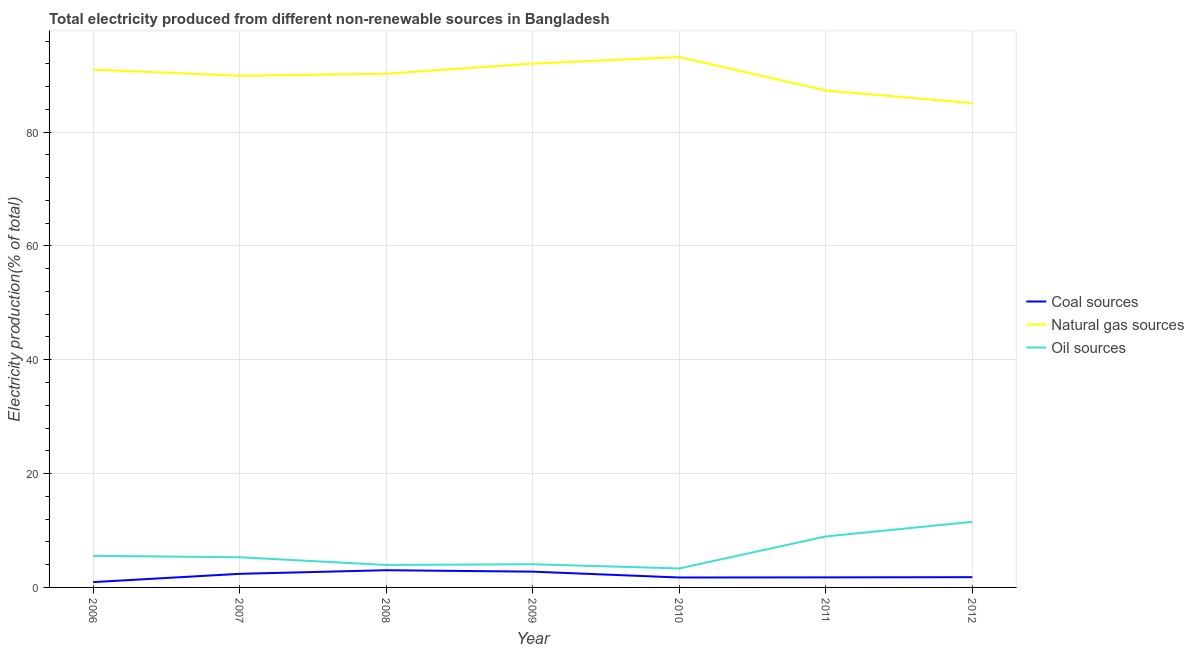How many different coloured lines are there?
Ensure brevity in your answer.  3. Does the line corresponding to percentage of electricity produced by oil sources intersect with the line corresponding to percentage of electricity produced by natural gas?
Your answer should be compact. No. Is the number of lines equal to the number of legend labels?
Provide a succinct answer. Yes. What is the percentage of electricity produced by oil sources in 2007?
Offer a terse response. 5.3. Across all years, what is the maximum percentage of electricity produced by natural gas?
Offer a terse response. 93.18. Across all years, what is the minimum percentage of electricity produced by coal?
Ensure brevity in your answer.  0.93. In which year was the percentage of electricity produced by oil sources minimum?
Give a very brief answer. 2010. What is the total percentage of electricity produced by oil sources in the graph?
Offer a very short reply. 42.69. What is the difference between the percentage of electricity produced by natural gas in 2009 and that in 2011?
Make the answer very short. 4.73. What is the difference between the percentage of electricity produced by natural gas in 2012 and the percentage of electricity produced by oil sources in 2006?
Keep it short and to the point. 79.54. What is the average percentage of electricity produced by coal per year?
Give a very brief answer. 2.06. In the year 2012, what is the difference between the percentage of electricity produced by coal and percentage of electricity produced by natural gas?
Your answer should be very brief. -83.29. What is the ratio of the percentage of electricity produced by coal in 2010 to that in 2011?
Offer a very short reply. 0.99. What is the difference between the highest and the second highest percentage of electricity produced by natural gas?
Offer a very short reply. 1.14. What is the difference between the highest and the lowest percentage of electricity produced by oil sources?
Provide a succinct answer. 8.19. Is the sum of the percentage of electricity produced by natural gas in 2008 and 2009 greater than the maximum percentage of electricity produced by oil sources across all years?
Ensure brevity in your answer.  Yes. Does the percentage of electricity produced by natural gas monotonically increase over the years?
Give a very brief answer. No. Is the percentage of electricity produced by oil sources strictly less than the percentage of electricity produced by natural gas over the years?
Your answer should be very brief. Yes. How many lines are there?
Your answer should be compact. 3. How many years are there in the graph?
Offer a terse response. 7. Where does the legend appear in the graph?
Your answer should be compact. Center right. How are the legend labels stacked?
Provide a succinct answer. Vertical. What is the title of the graph?
Provide a succinct answer. Total electricity produced from different non-renewable sources in Bangladesh. What is the label or title of the Y-axis?
Offer a terse response. Electricity production(% of total). What is the Electricity production(% of total) of Coal sources in 2006?
Your response must be concise. 0.93. What is the Electricity production(% of total) in Natural gas sources in 2006?
Provide a succinct answer. 90.98. What is the Electricity production(% of total) in Oil sources in 2006?
Offer a terse response. 5.55. What is the Electricity production(% of total) in Coal sources in 2007?
Offer a terse response. 2.39. What is the Electricity production(% of total) in Natural gas sources in 2007?
Give a very brief answer. 89.9. What is the Electricity production(% of total) of Oil sources in 2007?
Offer a very short reply. 5.3. What is the Electricity production(% of total) of Coal sources in 2008?
Keep it short and to the point. 3.02. What is the Electricity production(% of total) of Natural gas sources in 2008?
Offer a very short reply. 90.26. What is the Electricity production(% of total) in Oil sources in 2008?
Your answer should be compact. 3.95. What is the Electricity production(% of total) of Coal sources in 2009?
Your answer should be very brief. 2.77. What is the Electricity production(% of total) of Natural gas sources in 2009?
Your answer should be very brief. 92.03. What is the Electricity production(% of total) in Oil sources in 2009?
Make the answer very short. 4.08. What is the Electricity production(% of total) of Coal sources in 2010?
Your answer should be very brief. 1.74. What is the Electricity production(% of total) of Natural gas sources in 2010?
Keep it short and to the point. 93.18. What is the Electricity production(% of total) of Oil sources in 2010?
Offer a terse response. 3.33. What is the Electricity production(% of total) in Coal sources in 2011?
Give a very brief answer. 1.77. What is the Electricity production(% of total) in Natural gas sources in 2011?
Give a very brief answer. 87.31. What is the Electricity production(% of total) in Oil sources in 2011?
Give a very brief answer. 8.95. What is the Electricity production(% of total) in Coal sources in 2012?
Give a very brief answer. 1.8. What is the Electricity production(% of total) in Natural gas sources in 2012?
Give a very brief answer. 85.09. What is the Electricity production(% of total) in Oil sources in 2012?
Give a very brief answer. 11.53. Across all years, what is the maximum Electricity production(% of total) in Coal sources?
Provide a succinct answer. 3.02. Across all years, what is the maximum Electricity production(% of total) in Natural gas sources?
Ensure brevity in your answer.  93.18. Across all years, what is the maximum Electricity production(% of total) of Oil sources?
Your answer should be compact. 11.53. Across all years, what is the minimum Electricity production(% of total) in Coal sources?
Provide a short and direct response. 0.93. Across all years, what is the minimum Electricity production(% of total) of Natural gas sources?
Offer a terse response. 85.09. Across all years, what is the minimum Electricity production(% of total) of Oil sources?
Keep it short and to the point. 3.33. What is the total Electricity production(% of total) of Coal sources in the graph?
Your response must be concise. 14.43. What is the total Electricity production(% of total) in Natural gas sources in the graph?
Your response must be concise. 628.74. What is the total Electricity production(% of total) in Oil sources in the graph?
Offer a terse response. 42.69. What is the difference between the Electricity production(% of total) in Coal sources in 2006 and that in 2007?
Your answer should be very brief. -1.46. What is the difference between the Electricity production(% of total) of Oil sources in 2006 and that in 2007?
Provide a succinct answer. 0.25. What is the difference between the Electricity production(% of total) in Coal sources in 2006 and that in 2008?
Provide a short and direct response. -2.09. What is the difference between the Electricity production(% of total) in Natural gas sources in 2006 and that in 2008?
Give a very brief answer. 0.72. What is the difference between the Electricity production(% of total) in Oil sources in 2006 and that in 2008?
Your answer should be compact. 1.6. What is the difference between the Electricity production(% of total) in Coal sources in 2006 and that in 2009?
Provide a succinct answer. -1.84. What is the difference between the Electricity production(% of total) of Natural gas sources in 2006 and that in 2009?
Your answer should be compact. -1.06. What is the difference between the Electricity production(% of total) in Oil sources in 2006 and that in 2009?
Give a very brief answer. 1.48. What is the difference between the Electricity production(% of total) in Coal sources in 2006 and that in 2010?
Give a very brief answer. -0.81. What is the difference between the Electricity production(% of total) in Natural gas sources in 2006 and that in 2010?
Give a very brief answer. -2.2. What is the difference between the Electricity production(% of total) of Oil sources in 2006 and that in 2010?
Provide a short and direct response. 2.22. What is the difference between the Electricity production(% of total) of Coal sources in 2006 and that in 2011?
Provide a succinct answer. -0.83. What is the difference between the Electricity production(% of total) in Natural gas sources in 2006 and that in 2011?
Offer a terse response. 3.67. What is the difference between the Electricity production(% of total) of Oil sources in 2006 and that in 2011?
Your response must be concise. -3.4. What is the difference between the Electricity production(% of total) of Coal sources in 2006 and that in 2012?
Give a very brief answer. -0.87. What is the difference between the Electricity production(% of total) of Natural gas sources in 2006 and that in 2012?
Your answer should be very brief. 5.89. What is the difference between the Electricity production(% of total) in Oil sources in 2006 and that in 2012?
Keep it short and to the point. -5.97. What is the difference between the Electricity production(% of total) of Coal sources in 2007 and that in 2008?
Make the answer very short. -0.64. What is the difference between the Electricity production(% of total) of Natural gas sources in 2007 and that in 2008?
Keep it short and to the point. -0.36. What is the difference between the Electricity production(% of total) of Oil sources in 2007 and that in 2008?
Your answer should be compact. 1.35. What is the difference between the Electricity production(% of total) of Coal sources in 2007 and that in 2009?
Your answer should be compact. -0.38. What is the difference between the Electricity production(% of total) of Natural gas sources in 2007 and that in 2009?
Your answer should be compact. -2.14. What is the difference between the Electricity production(% of total) in Oil sources in 2007 and that in 2009?
Offer a terse response. 1.22. What is the difference between the Electricity production(% of total) of Coal sources in 2007 and that in 2010?
Provide a short and direct response. 0.65. What is the difference between the Electricity production(% of total) in Natural gas sources in 2007 and that in 2010?
Keep it short and to the point. -3.28. What is the difference between the Electricity production(% of total) in Oil sources in 2007 and that in 2010?
Ensure brevity in your answer.  1.96. What is the difference between the Electricity production(% of total) in Coal sources in 2007 and that in 2011?
Make the answer very short. 0.62. What is the difference between the Electricity production(% of total) in Natural gas sources in 2007 and that in 2011?
Your answer should be compact. 2.59. What is the difference between the Electricity production(% of total) in Oil sources in 2007 and that in 2011?
Keep it short and to the point. -3.66. What is the difference between the Electricity production(% of total) of Coal sources in 2007 and that in 2012?
Your answer should be very brief. 0.59. What is the difference between the Electricity production(% of total) in Natural gas sources in 2007 and that in 2012?
Your answer should be very brief. 4.81. What is the difference between the Electricity production(% of total) in Oil sources in 2007 and that in 2012?
Provide a short and direct response. -6.23. What is the difference between the Electricity production(% of total) of Coal sources in 2008 and that in 2009?
Offer a terse response. 0.25. What is the difference between the Electricity production(% of total) of Natural gas sources in 2008 and that in 2009?
Ensure brevity in your answer.  -1.78. What is the difference between the Electricity production(% of total) in Oil sources in 2008 and that in 2009?
Provide a short and direct response. -0.13. What is the difference between the Electricity production(% of total) in Coal sources in 2008 and that in 2010?
Keep it short and to the point. 1.28. What is the difference between the Electricity production(% of total) in Natural gas sources in 2008 and that in 2010?
Your answer should be compact. -2.92. What is the difference between the Electricity production(% of total) in Oil sources in 2008 and that in 2010?
Offer a terse response. 0.61. What is the difference between the Electricity production(% of total) of Coal sources in 2008 and that in 2011?
Offer a terse response. 1.26. What is the difference between the Electricity production(% of total) of Natural gas sources in 2008 and that in 2011?
Provide a succinct answer. 2.95. What is the difference between the Electricity production(% of total) in Oil sources in 2008 and that in 2011?
Your answer should be compact. -5. What is the difference between the Electricity production(% of total) of Coal sources in 2008 and that in 2012?
Keep it short and to the point. 1.22. What is the difference between the Electricity production(% of total) of Natural gas sources in 2008 and that in 2012?
Offer a very short reply. 5.17. What is the difference between the Electricity production(% of total) in Oil sources in 2008 and that in 2012?
Your answer should be very brief. -7.58. What is the difference between the Electricity production(% of total) in Coal sources in 2009 and that in 2010?
Provide a succinct answer. 1.03. What is the difference between the Electricity production(% of total) in Natural gas sources in 2009 and that in 2010?
Ensure brevity in your answer.  -1.14. What is the difference between the Electricity production(% of total) in Oil sources in 2009 and that in 2010?
Ensure brevity in your answer.  0.74. What is the difference between the Electricity production(% of total) of Natural gas sources in 2009 and that in 2011?
Your answer should be compact. 4.73. What is the difference between the Electricity production(% of total) in Oil sources in 2009 and that in 2011?
Make the answer very short. -4.88. What is the difference between the Electricity production(% of total) in Coal sources in 2009 and that in 2012?
Your response must be concise. 0.97. What is the difference between the Electricity production(% of total) in Natural gas sources in 2009 and that in 2012?
Keep it short and to the point. 6.95. What is the difference between the Electricity production(% of total) in Oil sources in 2009 and that in 2012?
Make the answer very short. -7.45. What is the difference between the Electricity production(% of total) of Coal sources in 2010 and that in 2011?
Your answer should be compact. -0.02. What is the difference between the Electricity production(% of total) of Natural gas sources in 2010 and that in 2011?
Offer a very short reply. 5.87. What is the difference between the Electricity production(% of total) of Oil sources in 2010 and that in 2011?
Your response must be concise. -5.62. What is the difference between the Electricity production(% of total) of Coal sources in 2010 and that in 2012?
Your answer should be very brief. -0.06. What is the difference between the Electricity production(% of total) in Natural gas sources in 2010 and that in 2012?
Ensure brevity in your answer.  8.09. What is the difference between the Electricity production(% of total) of Oil sources in 2010 and that in 2012?
Keep it short and to the point. -8.19. What is the difference between the Electricity production(% of total) in Coal sources in 2011 and that in 2012?
Offer a very short reply. -0.03. What is the difference between the Electricity production(% of total) in Natural gas sources in 2011 and that in 2012?
Offer a very short reply. 2.22. What is the difference between the Electricity production(% of total) in Oil sources in 2011 and that in 2012?
Your answer should be very brief. -2.57. What is the difference between the Electricity production(% of total) in Coal sources in 2006 and the Electricity production(% of total) in Natural gas sources in 2007?
Keep it short and to the point. -88.96. What is the difference between the Electricity production(% of total) of Coal sources in 2006 and the Electricity production(% of total) of Oil sources in 2007?
Make the answer very short. -4.36. What is the difference between the Electricity production(% of total) in Natural gas sources in 2006 and the Electricity production(% of total) in Oil sources in 2007?
Keep it short and to the point. 85.68. What is the difference between the Electricity production(% of total) in Coal sources in 2006 and the Electricity production(% of total) in Natural gas sources in 2008?
Make the answer very short. -89.32. What is the difference between the Electricity production(% of total) in Coal sources in 2006 and the Electricity production(% of total) in Oil sources in 2008?
Make the answer very short. -3.01. What is the difference between the Electricity production(% of total) in Natural gas sources in 2006 and the Electricity production(% of total) in Oil sources in 2008?
Make the answer very short. 87.03. What is the difference between the Electricity production(% of total) in Coal sources in 2006 and the Electricity production(% of total) in Natural gas sources in 2009?
Offer a very short reply. -91.1. What is the difference between the Electricity production(% of total) of Coal sources in 2006 and the Electricity production(% of total) of Oil sources in 2009?
Make the answer very short. -3.14. What is the difference between the Electricity production(% of total) in Natural gas sources in 2006 and the Electricity production(% of total) in Oil sources in 2009?
Provide a succinct answer. 86.9. What is the difference between the Electricity production(% of total) in Coal sources in 2006 and the Electricity production(% of total) in Natural gas sources in 2010?
Keep it short and to the point. -92.24. What is the difference between the Electricity production(% of total) of Coal sources in 2006 and the Electricity production(% of total) of Oil sources in 2010?
Give a very brief answer. -2.4. What is the difference between the Electricity production(% of total) of Natural gas sources in 2006 and the Electricity production(% of total) of Oil sources in 2010?
Give a very brief answer. 87.64. What is the difference between the Electricity production(% of total) in Coal sources in 2006 and the Electricity production(% of total) in Natural gas sources in 2011?
Offer a terse response. -86.37. What is the difference between the Electricity production(% of total) of Coal sources in 2006 and the Electricity production(% of total) of Oil sources in 2011?
Provide a succinct answer. -8.02. What is the difference between the Electricity production(% of total) of Natural gas sources in 2006 and the Electricity production(% of total) of Oil sources in 2011?
Provide a succinct answer. 82.02. What is the difference between the Electricity production(% of total) of Coal sources in 2006 and the Electricity production(% of total) of Natural gas sources in 2012?
Offer a terse response. -84.16. What is the difference between the Electricity production(% of total) of Coal sources in 2006 and the Electricity production(% of total) of Oil sources in 2012?
Keep it short and to the point. -10.59. What is the difference between the Electricity production(% of total) in Natural gas sources in 2006 and the Electricity production(% of total) in Oil sources in 2012?
Offer a terse response. 79.45. What is the difference between the Electricity production(% of total) in Coal sources in 2007 and the Electricity production(% of total) in Natural gas sources in 2008?
Your response must be concise. -87.87. What is the difference between the Electricity production(% of total) in Coal sources in 2007 and the Electricity production(% of total) in Oil sources in 2008?
Give a very brief answer. -1.56. What is the difference between the Electricity production(% of total) of Natural gas sources in 2007 and the Electricity production(% of total) of Oil sources in 2008?
Keep it short and to the point. 85.95. What is the difference between the Electricity production(% of total) of Coal sources in 2007 and the Electricity production(% of total) of Natural gas sources in 2009?
Make the answer very short. -89.65. What is the difference between the Electricity production(% of total) in Coal sources in 2007 and the Electricity production(% of total) in Oil sources in 2009?
Offer a terse response. -1.69. What is the difference between the Electricity production(% of total) in Natural gas sources in 2007 and the Electricity production(% of total) in Oil sources in 2009?
Keep it short and to the point. 85.82. What is the difference between the Electricity production(% of total) of Coal sources in 2007 and the Electricity production(% of total) of Natural gas sources in 2010?
Provide a short and direct response. -90.79. What is the difference between the Electricity production(% of total) in Coal sources in 2007 and the Electricity production(% of total) in Oil sources in 2010?
Ensure brevity in your answer.  -0.94. What is the difference between the Electricity production(% of total) of Natural gas sources in 2007 and the Electricity production(% of total) of Oil sources in 2010?
Ensure brevity in your answer.  86.56. What is the difference between the Electricity production(% of total) of Coal sources in 2007 and the Electricity production(% of total) of Natural gas sources in 2011?
Offer a terse response. -84.92. What is the difference between the Electricity production(% of total) of Coal sources in 2007 and the Electricity production(% of total) of Oil sources in 2011?
Make the answer very short. -6.56. What is the difference between the Electricity production(% of total) of Natural gas sources in 2007 and the Electricity production(% of total) of Oil sources in 2011?
Your response must be concise. 80.94. What is the difference between the Electricity production(% of total) of Coal sources in 2007 and the Electricity production(% of total) of Natural gas sources in 2012?
Provide a short and direct response. -82.7. What is the difference between the Electricity production(% of total) in Coal sources in 2007 and the Electricity production(% of total) in Oil sources in 2012?
Your answer should be very brief. -9.14. What is the difference between the Electricity production(% of total) of Natural gas sources in 2007 and the Electricity production(% of total) of Oil sources in 2012?
Your answer should be very brief. 78.37. What is the difference between the Electricity production(% of total) in Coal sources in 2008 and the Electricity production(% of total) in Natural gas sources in 2009?
Keep it short and to the point. -89.01. What is the difference between the Electricity production(% of total) of Coal sources in 2008 and the Electricity production(% of total) of Oil sources in 2009?
Offer a very short reply. -1.05. What is the difference between the Electricity production(% of total) in Natural gas sources in 2008 and the Electricity production(% of total) in Oil sources in 2009?
Your answer should be very brief. 86.18. What is the difference between the Electricity production(% of total) of Coal sources in 2008 and the Electricity production(% of total) of Natural gas sources in 2010?
Your response must be concise. -90.15. What is the difference between the Electricity production(% of total) in Coal sources in 2008 and the Electricity production(% of total) in Oil sources in 2010?
Offer a very short reply. -0.31. What is the difference between the Electricity production(% of total) in Natural gas sources in 2008 and the Electricity production(% of total) in Oil sources in 2010?
Provide a short and direct response. 86.93. What is the difference between the Electricity production(% of total) in Coal sources in 2008 and the Electricity production(% of total) in Natural gas sources in 2011?
Provide a short and direct response. -84.28. What is the difference between the Electricity production(% of total) in Coal sources in 2008 and the Electricity production(% of total) in Oil sources in 2011?
Ensure brevity in your answer.  -5.93. What is the difference between the Electricity production(% of total) of Natural gas sources in 2008 and the Electricity production(% of total) of Oil sources in 2011?
Your answer should be very brief. 81.31. What is the difference between the Electricity production(% of total) in Coal sources in 2008 and the Electricity production(% of total) in Natural gas sources in 2012?
Provide a short and direct response. -82.06. What is the difference between the Electricity production(% of total) in Coal sources in 2008 and the Electricity production(% of total) in Oil sources in 2012?
Make the answer very short. -8.5. What is the difference between the Electricity production(% of total) of Natural gas sources in 2008 and the Electricity production(% of total) of Oil sources in 2012?
Your answer should be very brief. 78.73. What is the difference between the Electricity production(% of total) of Coal sources in 2009 and the Electricity production(% of total) of Natural gas sources in 2010?
Provide a succinct answer. -90.41. What is the difference between the Electricity production(% of total) of Coal sources in 2009 and the Electricity production(% of total) of Oil sources in 2010?
Your answer should be compact. -0.56. What is the difference between the Electricity production(% of total) of Natural gas sources in 2009 and the Electricity production(% of total) of Oil sources in 2010?
Provide a short and direct response. 88.7. What is the difference between the Electricity production(% of total) of Coal sources in 2009 and the Electricity production(% of total) of Natural gas sources in 2011?
Provide a short and direct response. -84.54. What is the difference between the Electricity production(% of total) in Coal sources in 2009 and the Electricity production(% of total) in Oil sources in 2011?
Your response must be concise. -6.18. What is the difference between the Electricity production(% of total) of Natural gas sources in 2009 and the Electricity production(% of total) of Oil sources in 2011?
Give a very brief answer. 83.08. What is the difference between the Electricity production(% of total) in Coal sources in 2009 and the Electricity production(% of total) in Natural gas sources in 2012?
Your answer should be very brief. -82.32. What is the difference between the Electricity production(% of total) in Coal sources in 2009 and the Electricity production(% of total) in Oil sources in 2012?
Offer a terse response. -8.76. What is the difference between the Electricity production(% of total) of Natural gas sources in 2009 and the Electricity production(% of total) of Oil sources in 2012?
Offer a terse response. 80.51. What is the difference between the Electricity production(% of total) in Coal sources in 2010 and the Electricity production(% of total) in Natural gas sources in 2011?
Your answer should be compact. -85.56. What is the difference between the Electricity production(% of total) in Coal sources in 2010 and the Electricity production(% of total) in Oil sources in 2011?
Your response must be concise. -7.21. What is the difference between the Electricity production(% of total) of Natural gas sources in 2010 and the Electricity production(% of total) of Oil sources in 2011?
Your response must be concise. 84.23. What is the difference between the Electricity production(% of total) in Coal sources in 2010 and the Electricity production(% of total) in Natural gas sources in 2012?
Your answer should be compact. -83.35. What is the difference between the Electricity production(% of total) of Coal sources in 2010 and the Electricity production(% of total) of Oil sources in 2012?
Make the answer very short. -9.78. What is the difference between the Electricity production(% of total) of Natural gas sources in 2010 and the Electricity production(% of total) of Oil sources in 2012?
Offer a terse response. 81.65. What is the difference between the Electricity production(% of total) in Coal sources in 2011 and the Electricity production(% of total) in Natural gas sources in 2012?
Your response must be concise. -83.32. What is the difference between the Electricity production(% of total) in Coal sources in 2011 and the Electricity production(% of total) in Oil sources in 2012?
Give a very brief answer. -9.76. What is the difference between the Electricity production(% of total) in Natural gas sources in 2011 and the Electricity production(% of total) in Oil sources in 2012?
Keep it short and to the point. 75.78. What is the average Electricity production(% of total) in Coal sources per year?
Your answer should be compact. 2.06. What is the average Electricity production(% of total) in Natural gas sources per year?
Offer a terse response. 89.82. What is the average Electricity production(% of total) of Oil sources per year?
Keep it short and to the point. 6.1. In the year 2006, what is the difference between the Electricity production(% of total) of Coal sources and Electricity production(% of total) of Natural gas sources?
Provide a succinct answer. -90.04. In the year 2006, what is the difference between the Electricity production(% of total) of Coal sources and Electricity production(% of total) of Oil sources?
Provide a short and direct response. -4.62. In the year 2006, what is the difference between the Electricity production(% of total) in Natural gas sources and Electricity production(% of total) in Oil sources?
Offer a very short reply. 85.42. In the year 2007, what is the difference between the Electricity production(% of total) of Coal sources and Electricity production(% of total) of Natural gas sources?
Offer a terse response. -87.51. In the year 2007, what is the difference between the Electricity production(% of total) in Coal sources and Electricity production(% of total) in Oil sources?
Ensure brevity in your answer.  -2.91. In the year 2007, what is the difference between the Electricity production(% of total) of Natural gas sources and Electricity production(% of total) of Oil sources?
Your answer should be very brief. 84.6. In the year 2008, what is the difference between the Electricity production(% of total) of Coal sources and Electricity production(% of total) of Natural gas sources?
Give a very brief answer. -87.23. In the year 2008, what is the difference between the Electricity production(% of total) in Coal sources and Electricity production(% of total) in Oil sources?
Your answer should be compact. -0.92. In the year 2008, what is the difference between the Electricity production(% of total) in Natural gas sources and Electricity production(% of total) in Oil sources?
Your answer should be compact. 86.31. In the year 2009, what is the difference between the Electricity production(% of total) of Coal sources and Electricity production(% of total) of Natural gas sources?
Your response must be concise. -89.27. In the year 2009, what is the difference between the Electricity production(% of total) of Coal sources and Electricity production(% of total) of Oil sources?
Keep it short and to the point. -1.31. In the year 2009, what is the difference between the Electricity production(% of total) of Natural gas sources and Electricity production(% of total) of Oil sources?
Offer a very short reply. 87.96. In the year 2010, what is the difference between the Electricity production(% of total) of Coal sources and Electricity production(% of total) of Natural gas sources?
Your response must be concise. -91.44. In the year 2010, what is the difference between the Electricity production(% of total) in Coal sources and Electricity production(% of total) in Oil sources?
Your response must be concise. -1.59. In the year 2010, what is the difference between the Electricity production(% of total) of Natural gas sources and Electricity production(% of total) of Oil sources?
Your answer should be compact. 89.85. In the year 2011, what is the difference between the Electricity production(% of total) of Coal sources and Electricity production(% of total) of Natural gas sources?
Offer a very short reply. -85.54. In the year 2011, what is the difference between the Electricity production(% of total) in Coal sources and Electricity production(% of total) in Oil sources?
Offer a terse response. -7.19. In the year 2011, what is the difference between the Electricity production(% of total) of Natural gas sources and Electricity production(% of total) of Oil sources?
Ensure brevity in your answer.  78.35. In the year 2012, what is the difference between the Electricity production(% of total) in Coal sources and Electricity production(% of total) in Natural gas sources?
Give a very brief answer. -83.29. In the year 2012, what is the difference between the Electricity production(% of total) of Coal sources and Electricity production(% of total) of Oil sources?
Your response must be concise. -9.72. In the year 2012, what is the difference between the Electricity production(% of total) of Natural gas sources and Electricity production(% of total) of Oil sources?
Your answer should be compact. 73.56. What is the ratio of the Electricity production(% of total) of Coal sources in 2006 to that in 2007?
Provide a short and direct response. 0.39. What is the ratio of the Electricity production(% of total) of Oil sources in 2006 to that in 2007?
Your answer should be very brief. 1.05. What is the ratio of the Electricity production(% of total) of Coal sources in 2006 to that in 2008?
Provide a short and direct response. 0.31. What is the ratio of the Electricity production(% of total) of Natural gas sources in 2006 to that in 2008?
Your answer should be very brief. 1.01. What is the ratio of the Electricity production(% of total) of Oil sources in 2006 to that in 2008?
Your answer should be compact. 1.41. What is the ratio of the Electricity production(% of total) in Coal sources in 2006 to that in 2009?
Your answer should be very brief. 0.34. What is the ratio of the Electricity production(% of total) of Natural gas sources in 2006 to that in 2009?
Make the answer very short. 0.99. What is the ratio of the Electricity production(% of total) in Oil sources in 2006 to that in 2009?
Provide a succinct answer. 1.36. What is the ratio of the Electricity production(% of total) in Coal sources in 2006 to that in 2010?
Provide a succinct answer. 0.54. What is the ratio of the Electricity production(% of total) in Natural gas sources in 2006 to that in 2010?
Provide a short and direct response. 0.98. What is the ratio of the Electricity production(% of total) in Oil sources in 2006 to that in 2010?
Your answer should be very brief. 1.67. What is the ratio of the Electricity production(% of total) of Coal sources in 2006 to that in 2011?
Offer a terse response. 0.53. What is the ratio of the Electricity production(% of total) in Natural gas sources in 2006 to that in 2011?
Give a very brief answer. 1.04. What is the ratio of the Electricity production(% of total) of Oil sources in 2006 to that in 2011?
Your response must be concise. 0.62. What is the ratio of the Electricity production(% of total) of Coal sources in 2006 to that in 2012?
Your answer should be compact. 0.52. What is the ratio of the Electricity production(% of total) in Natural gas sources in 2006 to that in 2012?
Provide a succinct answer. 1.07. What is the ratio of the Electricity production(% of total) of Oil sources in 2006 to that in 2012?
Give a very brief answer. 0.48. What is the ratio of the Electricity production(% of total) of Coal sources in 2007 to that in 2008?
Keep it short and to the point. 0.79. What is the ratio of the Electricity production(% of total) of Oil sources in 2007 to that in 2008?
Your answer should be compact. 1.34. What is the ratio of the Electricity production(% of total) in Coal sources in 2007 to that in 2009?
Give a very brief answer. 0.86. What is the ratio of the Electricity production(% of total) of Natural gas sources in 2007 to that in 2009?
Make the answer very short. 0.98. What is the ratio of the Electricity production(% of total) of Oil sources in 2007 to that in 2009?
Your answer should be compact. 1.3. What is the ratio of the Electricity production(% of total) of Coal sources in 2007 to that in 2010?
Give a very brief answer. 1.37. What is the ratio of the Electricity production(% of total) of Natural gas sources in 2007 to that in 2010?
Provide a succinct answer. 0.96. What is the ratio of the Electricity production(% of total) in Oil sources in 2007 to that in 2010?
Provide a short and direct response. 1.59. What is the ratio of the Electricity production(% of total) in Coal sources in 2007 to that in 2011?
Keep it short and to the point. 1.35. What is the ratio of the Electricity production(% of total) in Natural gas sources in 2007 to that in 2011?
Your answer should be compact. 1.03. What is the ratio of the Electricity production(% of total) in Oil sources in 2007 to that in 2011?
Make the answer very short. 0.59. What is the ratio of the Electricity production(% of total) in Coal sources in 2007 to that in 2012?
Your answer should be very brief. 1.33. What is the ratio of the Electricity production(% of total) of Natural gas sources in 2007 to that in 2012?
Ensure brevity in your answer.  1.06. What is the ratio of the Electricity production(% of total) of Oil sources in 2007 to that in 2012?
Offer a terse response. 0.46. What is the ratio of the Electricity production(% of total) in Coal sources in 2008 to that in 2009?
Your answer should be very brief. 1.09. What is the ratio of the Electricity production(% of total) of Natural gas sources in 2008 to that in 2009?
Your response must be concise. 0.98. What is the ratio of the Electricity production(% of total) in Oil sources in 2008 to that in 2009?
Keep it short and to the point. 0.97. What is the ratio of the Electricity production(% of total) in Coal sources in 2008 to that in 2010?
Give a very brief answer. 1.73. What is the ratio of the Electricity production(% of total) in Natural gas sources in 2008 to that in 2010?
Your response must be concise. 0.97. What is the ratio of the Electricity production(% of total) in Oil sources in 2008 to that in 2010?
Your answer should be compact. 1.18. What is the ratio of the Electricity production(% of total) of Coal sources in 2008 to that in 2011?
Ensure brevity in your answer.  1.71. What is the ratio of the Electricity production(% of total) of Natural gas sources in 2008 to that in 2011?
Offer a very short reply. 1.03. What is the ratio of the Electricity production(% of total) in Oil sources in 2008 to that in 2011?
Keep it short and to the point. 0.44. What is the ratio of the Electricity production(% of total) of Coal sources in 2008 to that in 2012?
Your answer should be compact. 1.68. What is the ratio of the Electricity production(% of total) of Natural gas sources in 2008 to that in 2012?
Ensure brevity in your answer.  1.06. What is the ratio of the Electricity production(% of total) in Oil sources in 2008 to that in 2012?
Provide a succinct answer. 0.34. What is the ratio of the Electricity production(% of total) of Coal sources in 2009 to that in 2010?
Your answer should be very brief. 1.59. What is the ratio of the Electricity production(% of total) in Oil sources in 2009 to that in 2010?
Keep it short and to the point. 1.22. What is the ratio of the Electricity production(% of total) in Coal sources in 2009 to that in 2011?
Make the answer very short. 1.57. What is the ratio of the Electricity production(% of total) of Natural gas sources in 2009 to that in 2011?
Provide a short and direct response. 1.05. What is the ratio of the Electricity production(% of total) of Oil sources in 2009 to that in 2011?
Your response must be concise. 0.46. What is the ratio of the Electricity production(% of total) of Coal sources in 2009 to that in 2012?
Provide a succinct answer. 1.54. What is the ratio of the Electricity production(% of total) of Natural gas sources in 2009 to that in 2012?
Your answer should be very brief. 1.08. What is the ratio of the Electricity production(% of total) in Oil sources in 2009 to that in 2012?
Provide a succinct answer. 0.35. What is the ratio of the Electricity production(% of total) in Coal sources in 2010 to that in 2011?
Your answer should be compact. 0.99. What is the ratio of the Electricity production(% of total) of Natural gas sources in 2010 to that in 2011?
Your answer should be very brief. 1.07. What is the ratio of the Electricity production(% of total) of Oil sources in 2010 to that in 2011?
Ensure brevity in your answer.  0.37. What is the ratio of the Electricity production(% of total) of Coal sources in 2010 to that in 2012?
Offer a very short reply. 0.97. What is the ratio of the Electricity production(% of total) in Natural gas sources in 2010 to that in 2012?
Offer a terse response. 1.1. What is the ratio of the Electricity production(% of total) in Oil sources in 2010 to that in 2012?
Keep it short and to the point. 0.29. What is the ratio of the Electricity production(% of total) of Coal sources in 2011 to that in 2012?
Give a very brief answer. 0.98. What is the ratio of the Electricity production(% of total) of Natural gas sources in 2011 to that in 2012?
Ensure brevity in your answer.  1.03. What is the ratio of the Electricity production(% of total) of Oil sources in 2011 to that in 2012?
Your answer should be very brief. 0.78. What is the difference between the highest and the second highest Electricity production(% of total) in Coal sources?
Provide a succinct answer. 0.25. What is the difference between the highest and the second highest Electricity production(% of total) of Natural gas sources?
Provide a short and direct response. 1.14. What is the difference between the highest and the second highest Electricity production(% of total) in Oil sources?
Provide a short and direct response. 2.57. What is the difference between the highest and the lowest Electricity production(% of total) of Coal sources?
Provide a short and direct response. 2.09. What is the difference between the highest and the lowest Electricity production(% of total) in Natural gas sources?
Your response must be concise. 8.09. What is the difference between the highest and the lowest Electricity production(% of total) of Oil sources?
Provide a short and direct response. 8.19. 